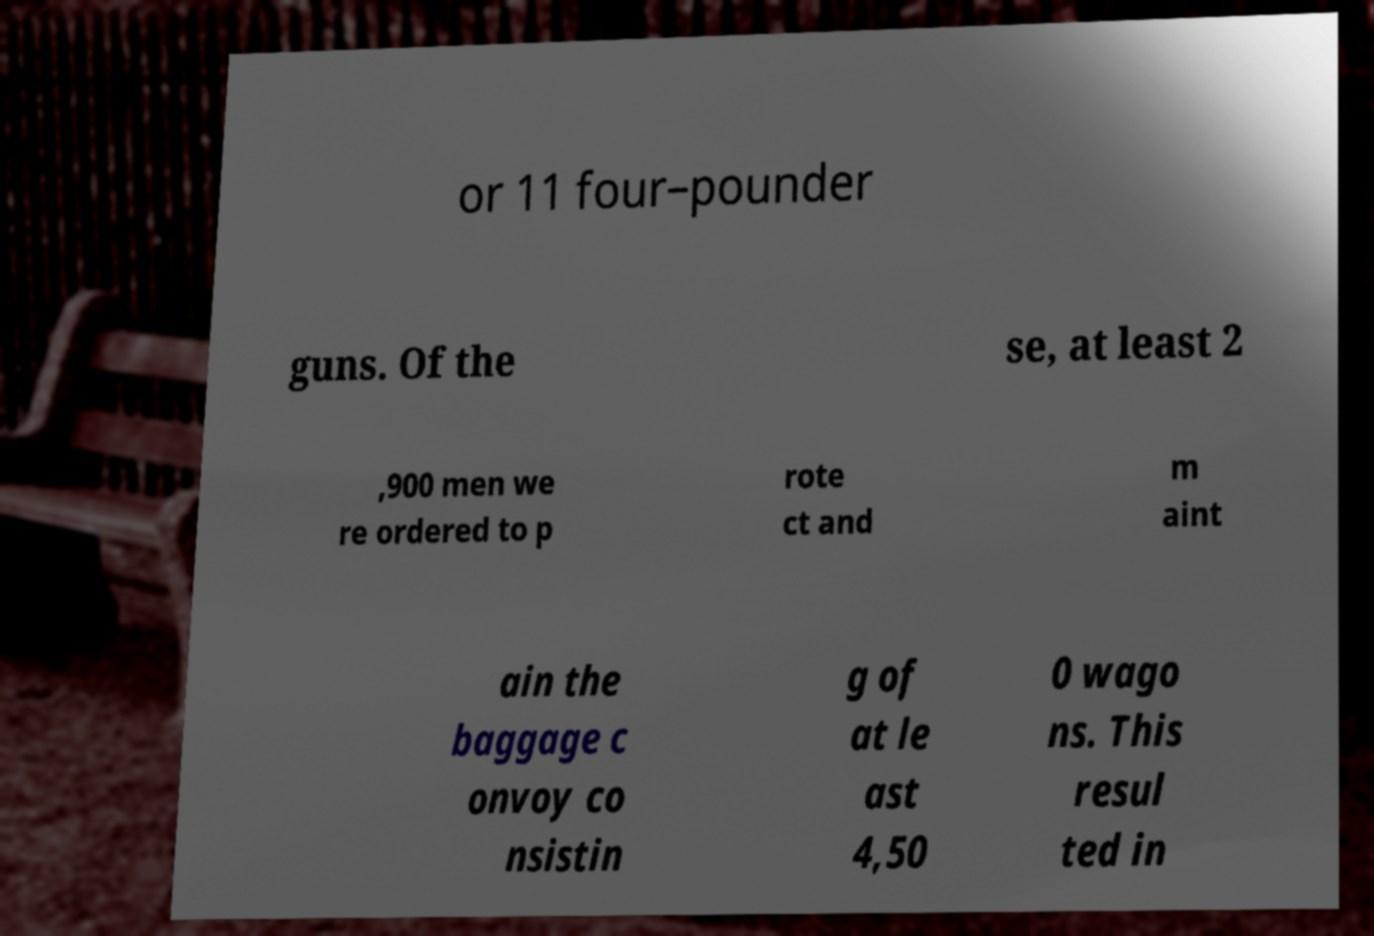Could you assist in decoding the text presented in this image and type it out clearly? or 11 four–pounder guns. Of the se, at least 2 ,900 men we re ordered to p rote ct and m aint ain the baggage c onvoy co nsistin g of at le ast 4,50 0 wago ns. This resul ted in 